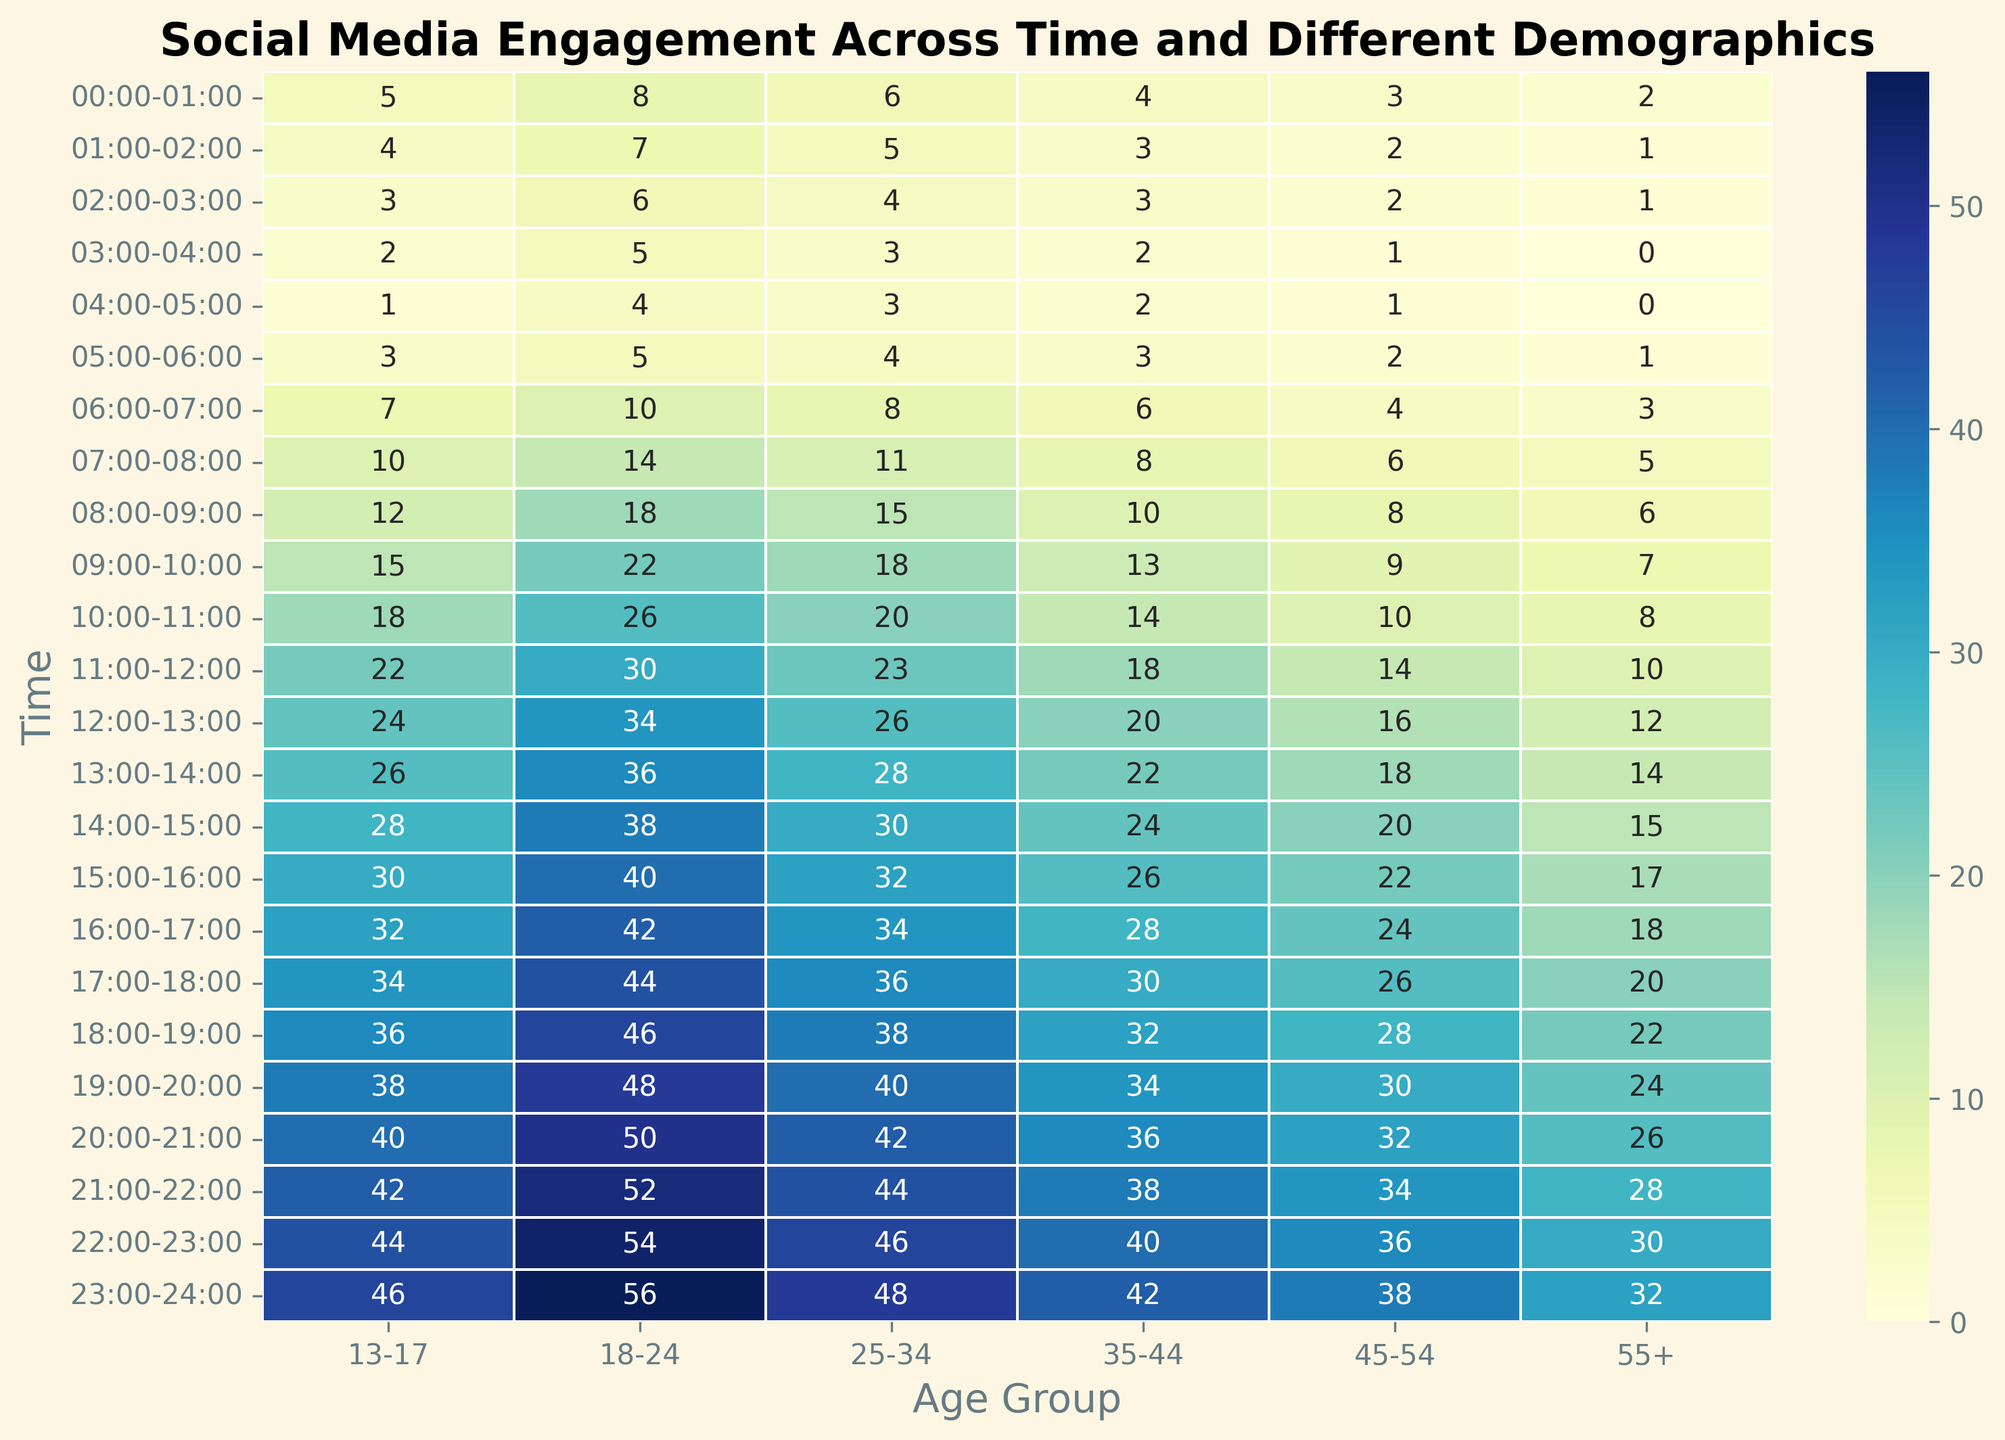What time period shows the highest engagement for the age group 18-24? To answer this question, locate the column corresponding to the age group 18-24 and find the time period with the highest numerical value. The highest value in this column is 56, which occurs at 23:00-24:00.
Answer: 23:00-24:00 What is the difference in engagement between the age groups 13-17 and 55+ at 16:00-17:00? To find the difference, locate the engagement values for both age groups at 16:00-17:00. The value for 13-17 is 32 and for 55+ is 18. Subtract the smaller value from the larger value: 32 - 18.
Answer: 14 During which time period does the age group 45-54 have the lowest engagement? Find the lowest value in the column corresponding to the age group 45-54. The lowest value is 1, which occurs during the time periods 03:00-04:00 and 04:00-05:00.
Answer: 03:00-04:00 or 04:00-05:00 What is the average engagement for the age group 25-34 from 08:00 to 12:00? First, find the engagement values for the age group 25-34 from 08:00 to 12:00: 15, 18, 20, 23. Sum these values (15 + 18 + 20 + 23 = 76). Divide the sum by the number of values (4) to get the average: 76 / 4.
Answer: 19 Compare the engagement of the age group 35-44 between 10:00-11:00 and 22:00-23:00. Which period has higher engagement? Locate the values for both time periods for the age group 35-44. For 10:00-11:00, the value is 14. For 22:00-23:00, the value is 40. Since 40 is greater than 14, 22:00-23:00 has higher engagement.
Answer: 22:00-23:00 Which age group has the highest engagement during the 20:00-21:00 period? Find the time period 20:00-21:00 and look across each age group's engagement values. The highest value is 50, which belongs to the age group 18-24.
Answer: 18-24 Does the engagement for the age group 13-17 increase or decrease from 00:00-01:00 to 03:00-04:00? Start at 00:00-01:00 and see the engagement value for 13-17 (5). Then, find the value for 03:00-04:00 (2). Since 5 is greater than 2, the engagement decreases.
Answer: Decrease What is the combined engagement for the age group 45-54 from 00:00 to 04:00? Locate the engagement values from 00:00 to 04:00 for the age group 45-54: 3, 2, 2, 1. Add these numbers together: 3 + 2 + 2 + 1.
Answer: 8 At what time period does the engagement in the age group 55+ cross the value of 20 for the first time? Scan the 55+ column from top to bottom to look for the first value above 20. The value 22 occurs at 18:00-19:00.
Answer: 18:00-19:00 